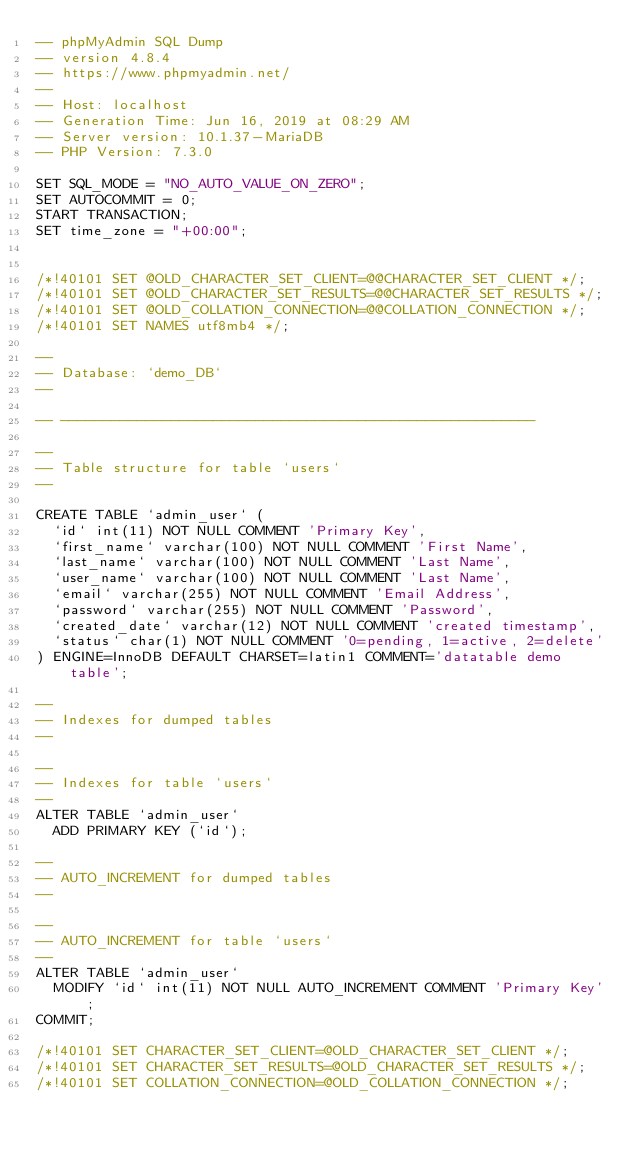Convert code to text. <code><loc_0><loc_0><loc_500><loc_500><_SQL_>-- phpMyAdmin SQL Dump
-- version 4.8.4
-- https://www.phpmyadmin.net/
--
-- Host: localhost
-- Generation Time: Jun 16, 2019 at 08:29 AM
-- Server version: 10.1.37-MariaDB
-- PHP Version: 7.3.0

SET SQL_MODE = "NO_AUTO_VALUE_ON_ZERO";
SET AUTOCOMMIT = 0;
START TRANSACTION;
SET time_zone = "+00:00";


/*!40101 SET @OLD_CHARACTER_SET_CLIENT=@@CHARACTER_SET_CLIENT */;
/*!40101 SET @OLD_CHARACTER_SET_RESULTS=@@CHARACTER_SET_RESULTS */;
/*!40101 SET @OLD_COLLATION_CONNECTION=@@COLLATION_CONNECTION */;
/*!40101 SET NAMES utf8mb4 */;

--
-- Database: `demo_DB`
--

-- --------------------------------------------------------

--
-- Table structure for table `users`
--

CREATE TABLE `admin_user` (
  `id` int(11) NOT NULL COMMENT 'Primary Key',
  `first_name` varchar(100) NOT NULL COMMENT 'First Name',
  `last_name` varchar(100) NOT NULL COMMENT 'Last Name',
  `user_name` varchar(100) NOT NULL COMMENT 'Last Name',
  `email` varchar(255) NOT NULL COMMENT 'Email Address',
  `password` varchar(255) NOT NULL COMMENT 'Password',
  `created_date` varchar(12) NOT NULL COMMENT 'created timestamp',
  `status` char(1) NOT NULL COMMENT '0=pending, 1=active, 2=delete'
) ENGINE=InnoDB DEFAULT CHARSET=latin1 COMMENT='datatable demo table';

--
-- Indexes for dumped tables
--

--
-- Indexes for table `users`
--
ALTER TABLE `admin_user`
  ADD PRIMARY KEY (`id`);

--
-- AUTO_INCREMENT for dumped tables
--

--
-- AUTO_INCREMENT for table `users`
--
ALTER TABLE `admin_user`
  MODIFY `id` int(11) NOT NULL AUTO_INCREMENT COMMENT 'Primary Key';
COMMIT;

/*!40101 SET CHARACTER_SET_CLIENT=@OLD_CHARACTER_SET_CLIENT */;
/*!40101 SET CHARACTER_SET_RESULTS=@OLD_CHARACTER_SET_RESULTS */;
/*!40101 SET COLLATION_CONNECTION=@OLD_COLLATION_CONNECTION */;
</code> 